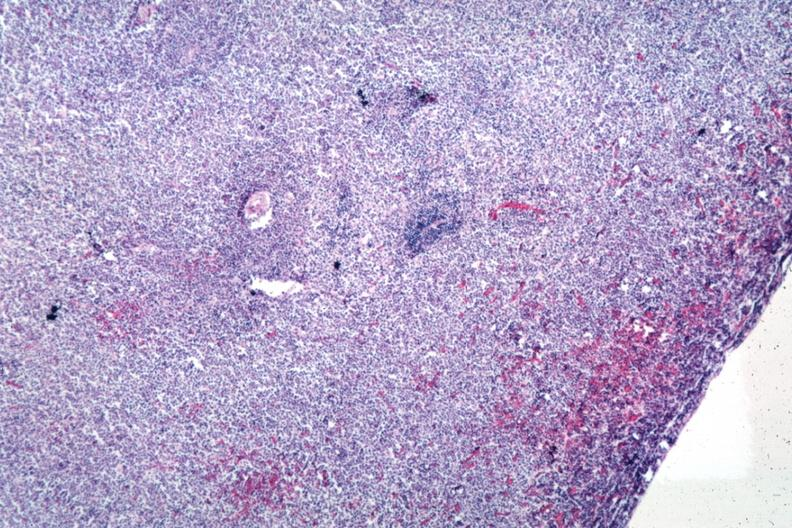does cranial artery show sheets of lymphoma cells?
Answer the question using a single word or phrase. No 